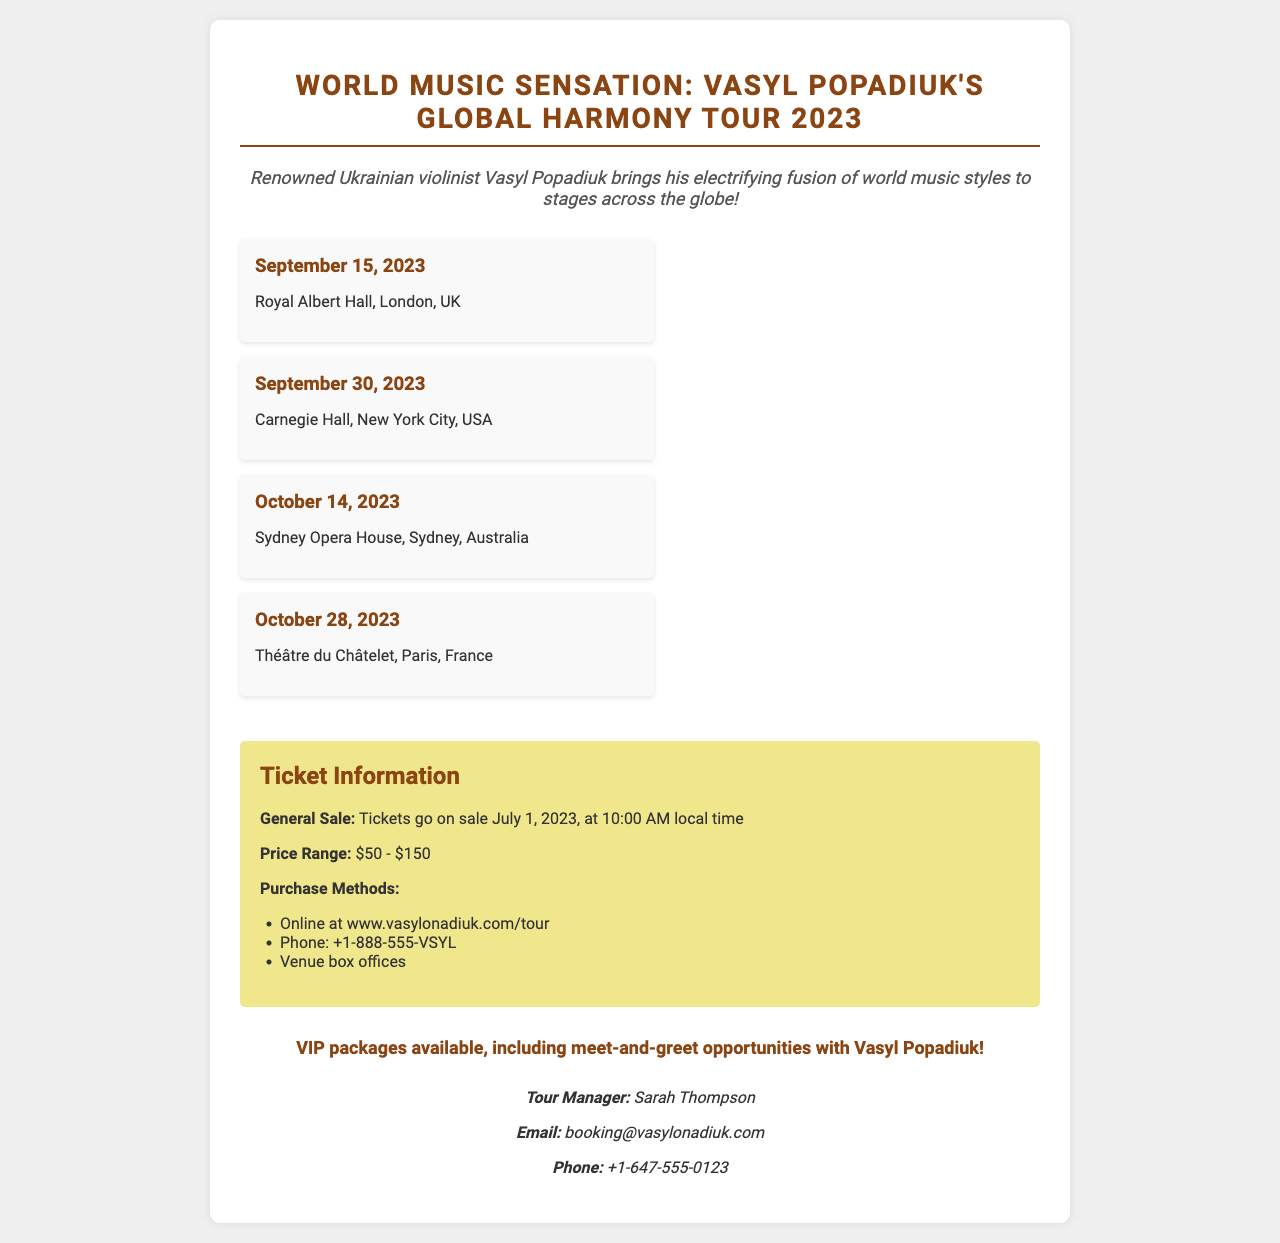What is the title of the tour? The title of the tour is prominently displayed at the top of the document.
Answer: Global Harmony Tour 2023 When does the ticket sale start? The ticket sale date is mentioned in the ticket information section.
Answer: July 1, 2023 What is the price range of the tickets? The price range is specified in the ticket information section.
Answer: $50 - $150 How many concert dates are listed? The number of concert dates can be counted from the tour dates section.
Answer: 4 What is the venue for the concert on October 14, 2023? The venue is mentioned in the tour dates section corresponding to that date.
Answer: Sydney Opera House Who is the tour manager? The tour manager's name is found in the contact information section.
Answer: Sarah Thompson What special package is mentioned in the document? The document includes information about a special opportunity highlighted in the ticket info section.
Answer: VIP packages Which city hosts the concert on September 30, 2023? The city is specified alongside the concert date in the tour dates section.
Answer: New York City How can tickets be purchased? The methods for purchasing tickets are listed under ticket information.
Answer: Online, Phone, Venue box offices 